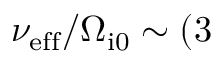<formula> <loc_0><loc_0><loc_500><loc_500>\nu _ { e f f } / \Omega _ { i 0 } \sim ( 3</formula> 